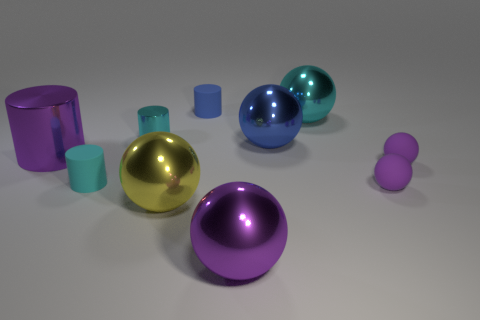Subtract all big metal spheres. How many spheres are left? 2 Subtract 1 balls. How many balls are left? 5 Subtract all purple cylinders. How many cylinders are left? 3 Subtract all cylinders. How many objects are left? 6 Subtract all yellow spheres. How many blue cylinders are left? 1 Add 6 cyan matte cylinders. How many cyan matte cylinders exist? 7 Subtract 1 blue cylinders. How many objects are left? 9 Subtract all blue cylinders. Subtract all brown blocks. How many cylinders are left? 3 Subtract all small blue things. Subtract all purple metallic balls. How many objects are left? 8 Add 7 rubber spheres. How many rubber spheres are left? 9 